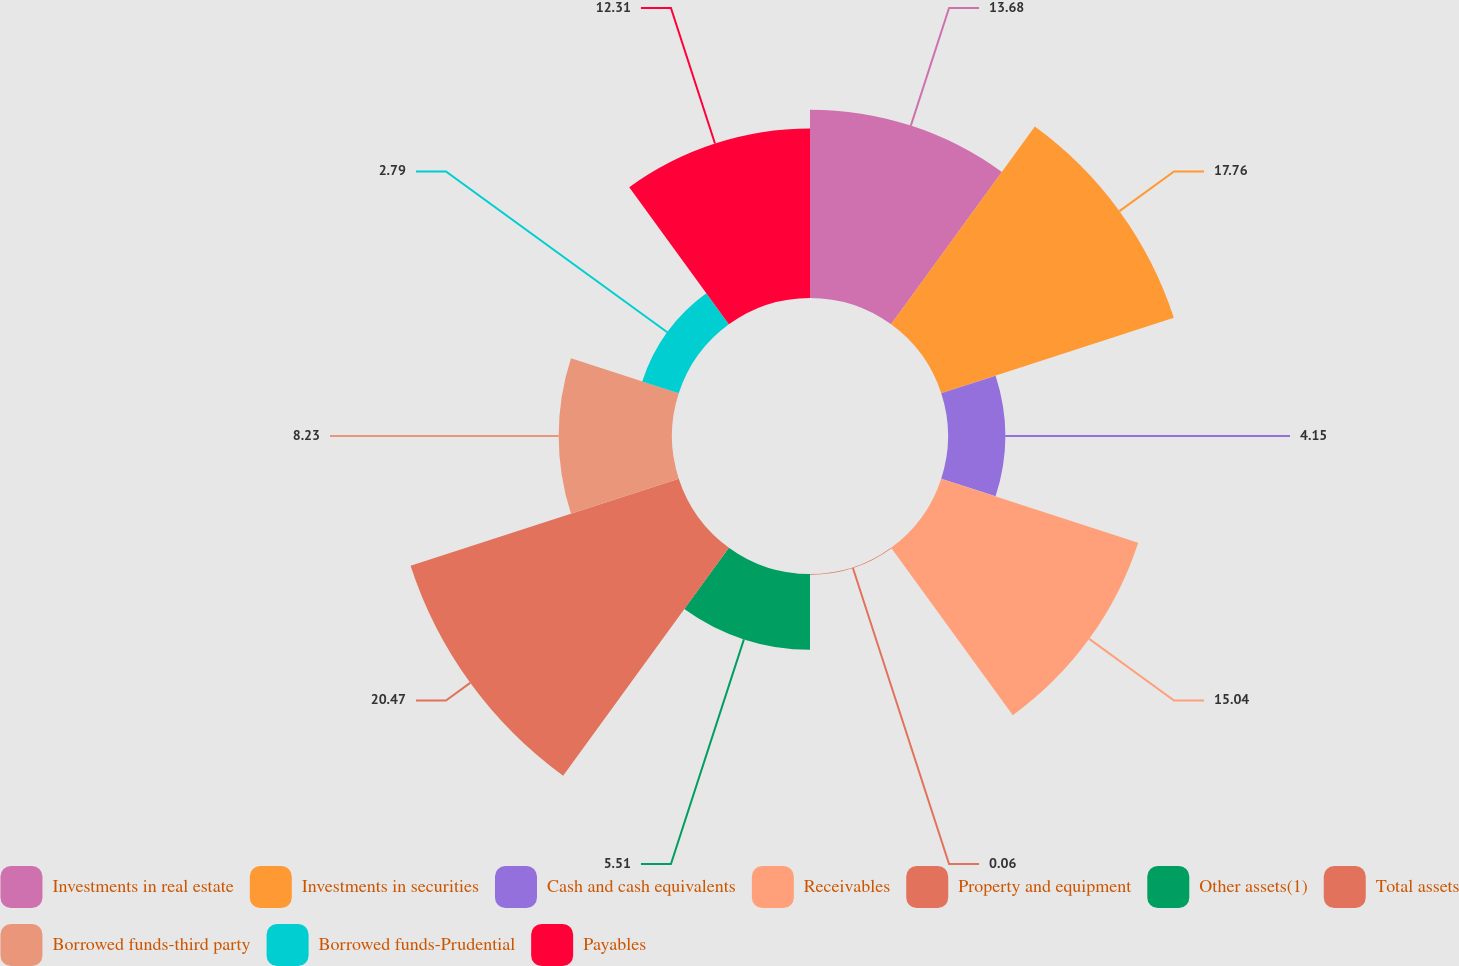Convert chart. <chart><loc_0><loc_0><loc_500><loc_500><pie_chart><fcel>Investments in real estate<fcel>Investments in securities<fcel>Cash and cash equivalents<fcel>Receivables<fcel>Property and equipment<fcel>Other assets(1)<fcel>Total assets<fcel>Borrowed funds-third party<fcel>Borrowed funds-Prudential<fcel>Payables<nl><fcel>13.68%<fcel>17.76%<fcel>4.15%<fcel>15.04%<fcel>0.06%<fcel>5.51%<fcel>20.48%<fcel>8.23%<fcel>2.79%<fcel>12.31%<nl></chart> 